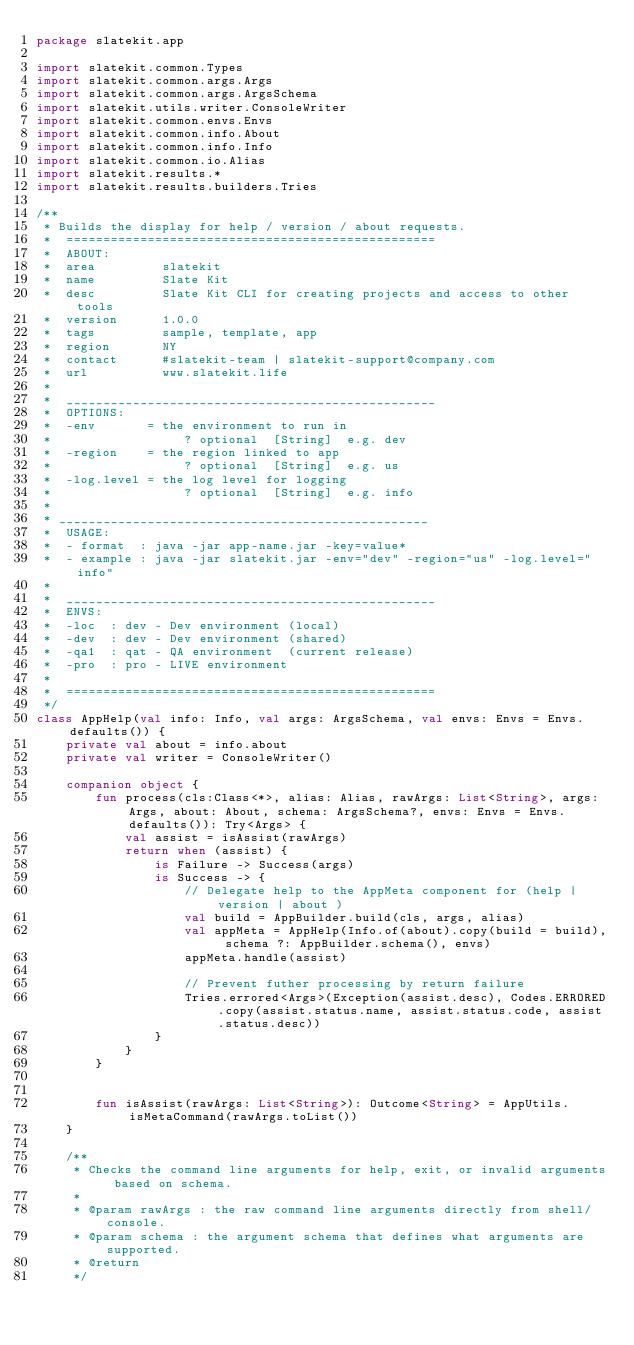<code> <loc_0><loc_0><loc_500><loc_500><_Kotlin_>package slatekit.app

import slatekit.common.Types
import slatekit.common.args.Args
import slatekit.common.args.ArgsSchema
import slatekit.utils.writer.ConsoleWriter
import slatekit.common.envs.Envs
import slatekit.common.info.About
import slatekit.common.info.Info
import slatekit.common.io.Alias
import slatekit.results.*
import slatekit.results.builders.Tries

/**
 * Builds the display for help / version / about requests.
 *  ==================================================
 *  ABOUT:
 *  area         slatekit
 *  name         Slate Kit
 *  desc         Slate Kit CLI for creating projects and access to other tools
 *  version      1.0.0
 *  tags         sample, template, app
 *  region       NY
 *  contact      #slatekit-team | slatekit-support@company.com
 *  url          www.slatekit.life
 *
 *  __________________________________________________
 *  OPTIONS:
 *  -env       = the environment to run in
 *                  ? optional  [String]  e.g. dev
 *  -region    = the region linked to app
 *                  ? optional  [String]  e.g. us
 *  -log.level = the log level for logging
 *                  ? optional  [String]  e.g. info
 *
 * __________________________________________________
 *  USAGE:
 *  - format  : java -jar app-name.jar -key=value*
 *  - example : java -jar slatekit.jar -env="dev" -region="us" -log.level="info"
 *
 *  __________________________________________________
 *  ENVS:
 *  -loc  : dev - Dev environment (local)
 *  -dev  : dev - Dev environment (shared)
 *  -qa1  : qat - QA environment  (current release)
 *  -pro  : pro - LIVE environment
 *
 *  ==================================================
 */
class AppHelp(val info: Info, val args: ArgsSchema, val envs: Envs = Envs.defaults()) {
    private val about = info.about
    private val writer = ConsoleWriter()

    companion object {
        fun process(cls:Class<*>, alias: Alias, rawArgs: List<String>, args: Args, about: About, schema: ArgsSchema?, envs: Envs = Envs.defaults()): Try<Args> {
            val assist = isAssist(rawArgs)
            return when (assist) {
                is Failure -> Success(args)
                is Success -> {
                    // Delegate help to the AppMeta component for (help | version | about )
                    val build = AppBuilder.build(cls, args, alias)
                    val appMeta = AppHelp(Info.of(about).copy(build = build), schema ?: AppBuilder.schema(), envs)
                    appMeta.handle(assist)

                    // Prevent futher processing by return failure
                    Tries.errored<Args>(Exception(assist.desc), Codes.ERRORED.copy(assist.status.name, assist.status.code, assist.status.desc))
                }
            }
        }


        fun isAssist(rawArgs: List<String>): Outcome<String> = AppUtils.isMetaCommand(rawArgs.toList())
    }

    /**
     * Checks the command line arguments for help, exit, or invalid arguments based on schema.
     *
     * @param rawArgs : the raw command line arguments directly from shell/console.
     * @param schema : the argument schema that defines what arguments are supported.
     * @return
     */</code> 